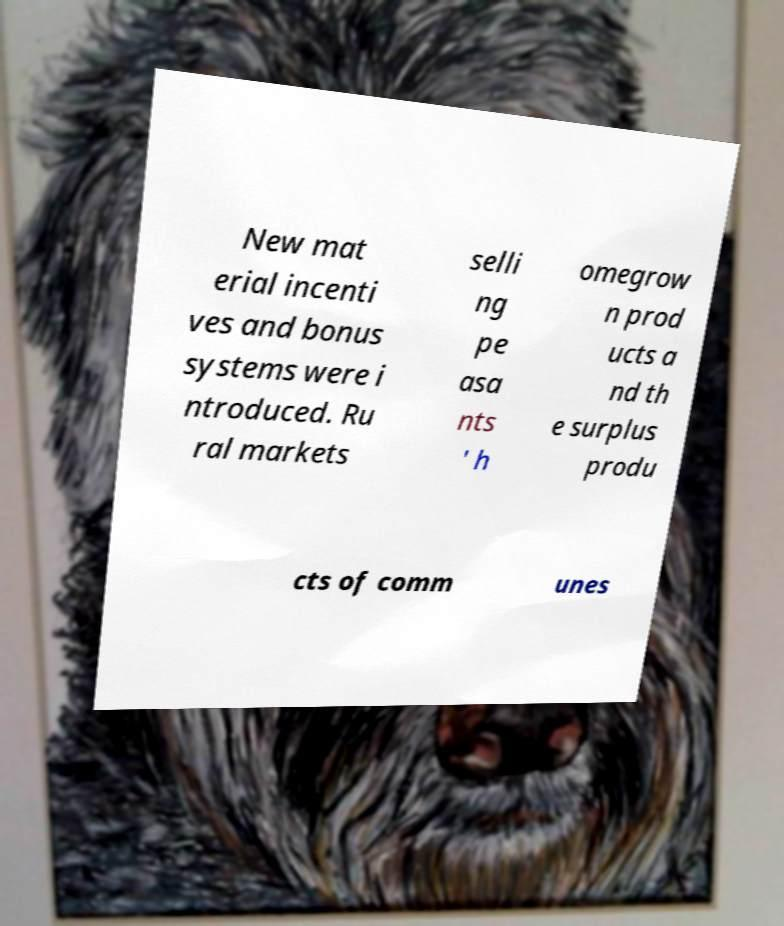Please identify and transcribe the text found in this image. New mat erial incenti ves and bonus systems were i ntroduced. Ru ral markets selli ng pe asa nts ' h omegrow n prod ucts a nd th e surplus produ cts of comm unes 